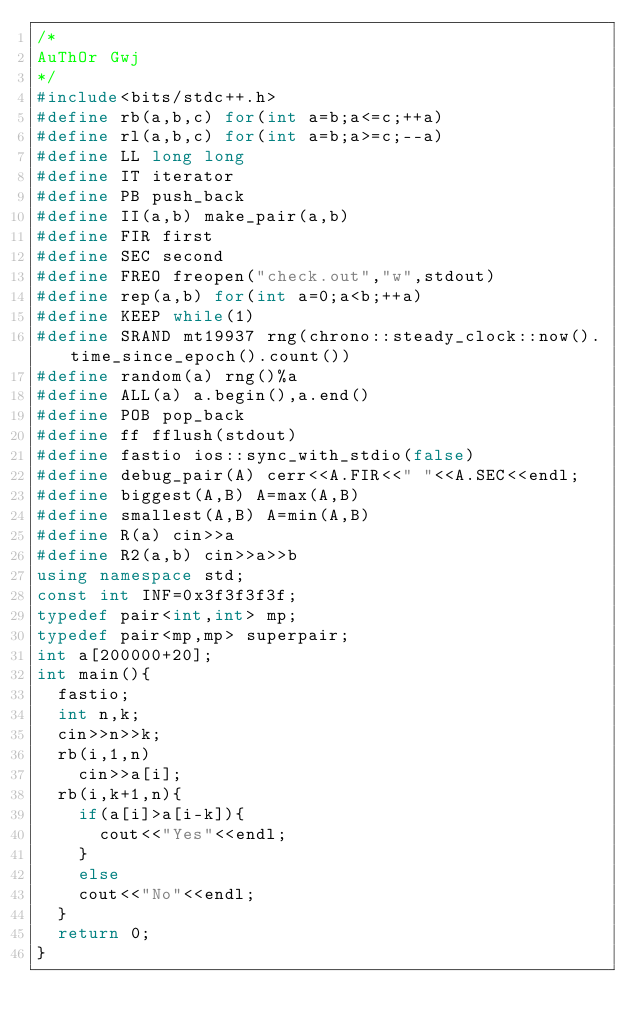<code> <loc_0><loc_0><loc_500><loc_500><_C++_>/*
AuThOr Gwj
*/
#include<bits/stdc++.h>
#define rb(a,b,c) for(int a=b;a<=c;++a)
#define rl(a,b,c) for(int a=b;a>=c;--a)
#define LL long long
#define IT iterator
#define PB push_back
#define II(a,b) make_pair(a,b)
#define FIR first
#define SEC second
#define FREO freopen("check.out","w",stdout)
#define rep(a,b) for(int a=0;a<b;++a)
#define KEEP while(1)
#define SRAND mt19937 rng(chrono::steady_clock::now().time_since_epoch().count())
#define random(a) rng()%a
#define ALL(a) a.begin(),a.end()
#define POB pop_back
#define ff fflush(stdout)
#define fastio ios::sync_with_stdio(false)
#define debug_pair(A) cerr<<A.FIR<<" "<<A.SEC<<endl;
#define biggest(A,B) A=max(A,B)
#define smallest(A,B) A=min(A,B)
#define R(a) cin>>a
#define R2(a,b) cin>>a>>b
using namespace std;
const int INF=0x3f3f3f3f;
typedef pair<int,int> mp;
typedef pair<mp,mp> superpair;
int a[200000+20];
int main(){
	fastio;
	int n,k;
	cin>>n>>k;
	rb(i,1,n)
		cin>>a[i];
	rb(i,k+1,n){
		if(a[i]>a[i-k]){
			cout<<"Yes"<<endl;
		}
		else
		cout<<"No"<<endl;
	}
	return 0;
}
</code> 